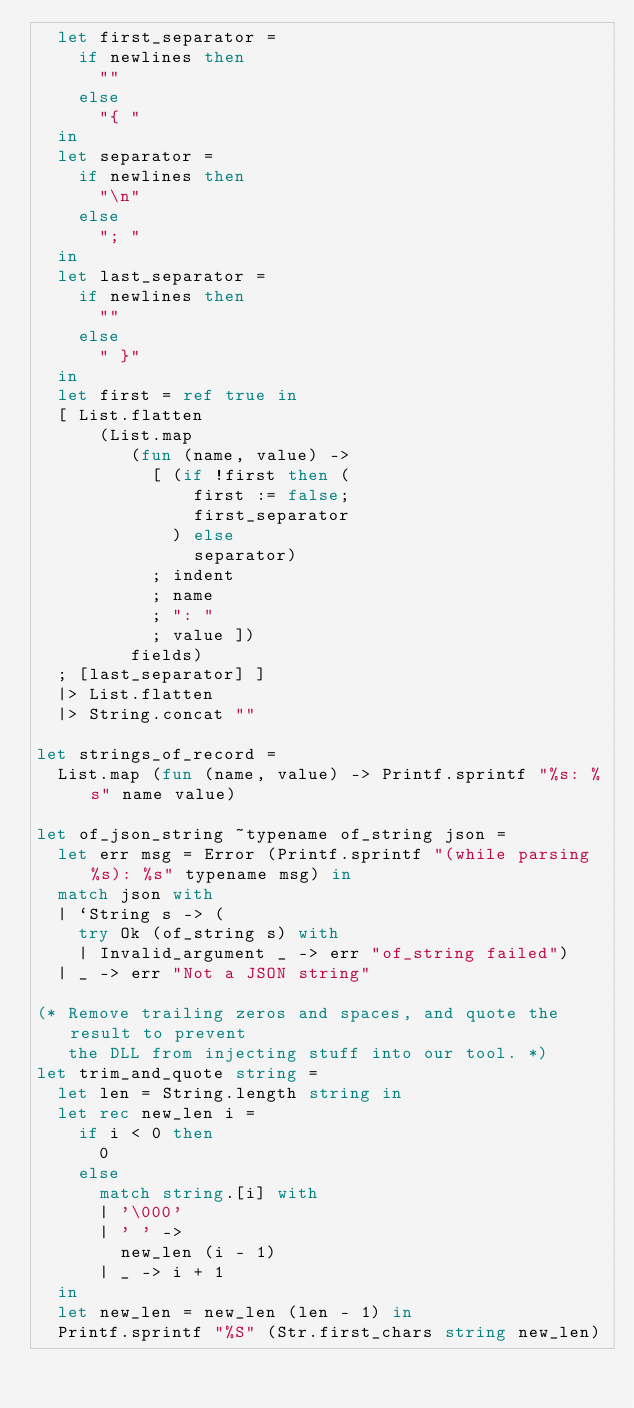Convert code to text. <code><loc_0><loc_0><loc_500><loc_500><_OCaml_>  let first_separator =
    if newlines then
      ""
    else
      "{ "
  in
  let separator =
    if newlines then
      "\n"
    else
      "; "
  in
  let last_separator =
    if newlines then
      ""
    else
      " }"
  in
  let first = ref true in
  [ List.flatten
      (List.map
         (fun (name, value) ->
           [ (if !first then (
               first := false;
               first_separator
             ) else
               separator)
           ; indent
           ; name
           ; ": "
           ; value ])
         fields)
  ; [last_separator] ]
  |> List.flatten
  |> String.concat ""

let strings_of_record =
  List.map (fun (name, value) -> Printf.sprintf "%s: %s" name value)

let of_json_string ~typename of_string json =
  let err msg = Error (Printf.sprintf "(while parsing %s): %s" typename msg) in
  match json with
  | `String s -> (
    try Ok (of_string s) with
    | Invalid_argument _ -> err "of_string failed")
  | _ -> err "Not a JSON string"

(* Remove trailing zeros and spaces, and quote the result to prevent
   the DLL from injecting stuff into our tool. *)
let trim_and_quote string =
  let len = String.length string in
  let rec new_len i =
    if i < 0 then
      0
    else
      match string.[i] with
      | '\000'
      | ' ' ->
        new_len (i - 1)
      | _ -> i + 1
  in
  let new_len = new_len (len - 1) in
  Printf.sprintf "%S" (Str.first_chars string new_len)
</code> 